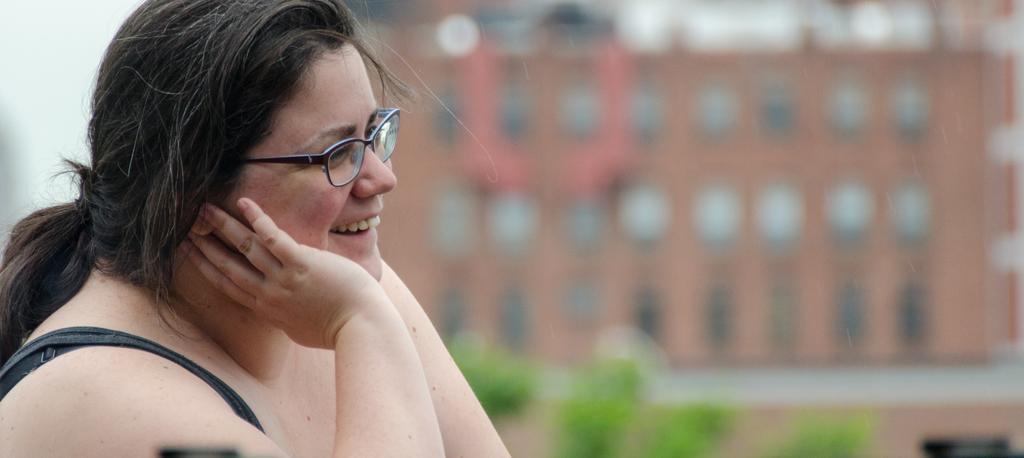Please provide a concise description of this image. In this picture we can see a woman wore a spectacle and smiling and in the background we can see a building, plants and it is blur. 